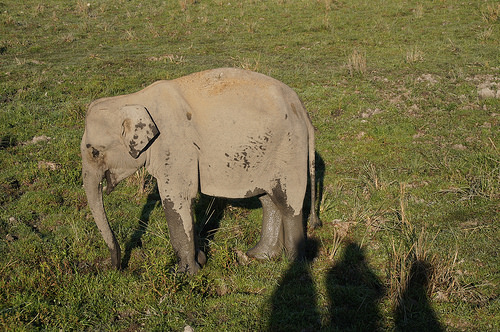<image>
Is the shadow on the grass? Yes. Looking at the image, I can see the shadow is positioned on top of the grass, with the grass providing support. Is the shadow behind the elephant? Yes. From this viewpoint, the shadow is positioned behind the elephant, with the elephant partially or fully occluding the shadow. Where is the shadow in relation to the elephant? Is it next to the elephant? Yes. The shadow is positioned adjacent to the elephant, located nearby in the same general area. 